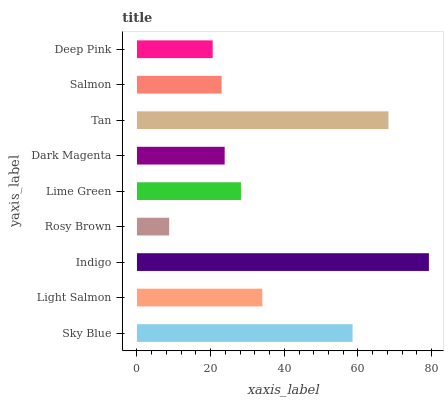Is Rosy Brown the minimum?
Answer yes or no. Yes. Is Indigo the maximum?
Answer yes or no. Yes. Is Light Salmon the minimum?
Answer yes or no. No. Is Light Salmon the maximum?
Answer yes or no. No. Is Sky Blue greater than Light Salmon?
Answer yes or no. Yes. Is Light Salmon less than Sky Blue?
Answer yes or no. Yes. Is Light Salmon greater than Sky Blue?
Answer yes or no. No. Is Sky Blue less than Light Salmon?
Answer yes or no. No. Is Lime Green the high median?
Answer yes or no. Yes. Is Lime Green the low median?
Answer yes or no. Yes. Is Deep Pink the high median?
Answer yes or no. No. Is Deep Pink the low median?
Answer yes or no. No. 